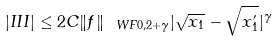Convert formula to latex. <formula><loc_0><loc_0><loc_500><loc_500>| I I I | \leq 2 C \| f \| _ { \ W F 0 , 2 + \gamma } | \sqrt { x _ { 1 } } - \sqrt { x _ { 1 } ^ { \prime } } | ^ { \gamma }</formula> 